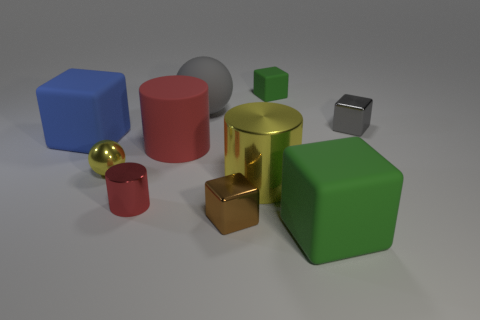Subtract 2 blocks. How many blocks are left? 3 Subtract all blue blocks. How many blocks are left? 4 Subtract all brown metal blocks. How many blocks are left? 4 Subtract all red cubes. Subtract all brown spheres. How many cubes are left? 5 Subtract all spheres. How many objects are left? 8 Subtract all big cyan rubber objects. Subtract all green things. How many objects are left? 8 Add 7 large blue cubes. How many large blue cubes are left? 8 Add 7 small brown rubber blocks. How many small brown rubber blocks exist? 7 Subtract 1 gray spheres. How many objects are left? 9 